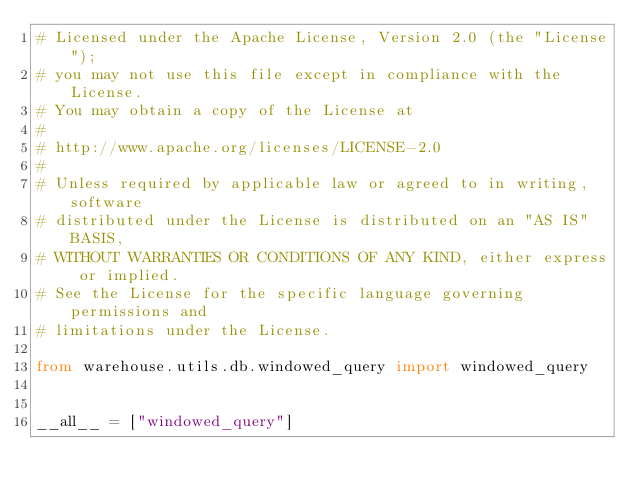Convert code to text. <code><loc_0><loc_0><loc_500><loc_500><_Python_># Licensed under the Apache License, Version 2.0 (the "License");
# you may not use this file except in compliance with the License.
# You may obtain a copy of the License at
#
# http://www.apache.org/licenses/LICENSE-2.0
#
# Unless required by applicable law or agreed to in writing, software
# distributed under the License is distributed on an "AS IS" BASIS,
# WITHOUT WARRANTIES OR CONDITIONS OF ANY KIND, either express or implied.
# See the License for the specific language governing permissions and
# limitations under the License.

from warehouse.utils.db.windowed_query import windowed_query


__all__ = ["windowed_query"]
</code> 